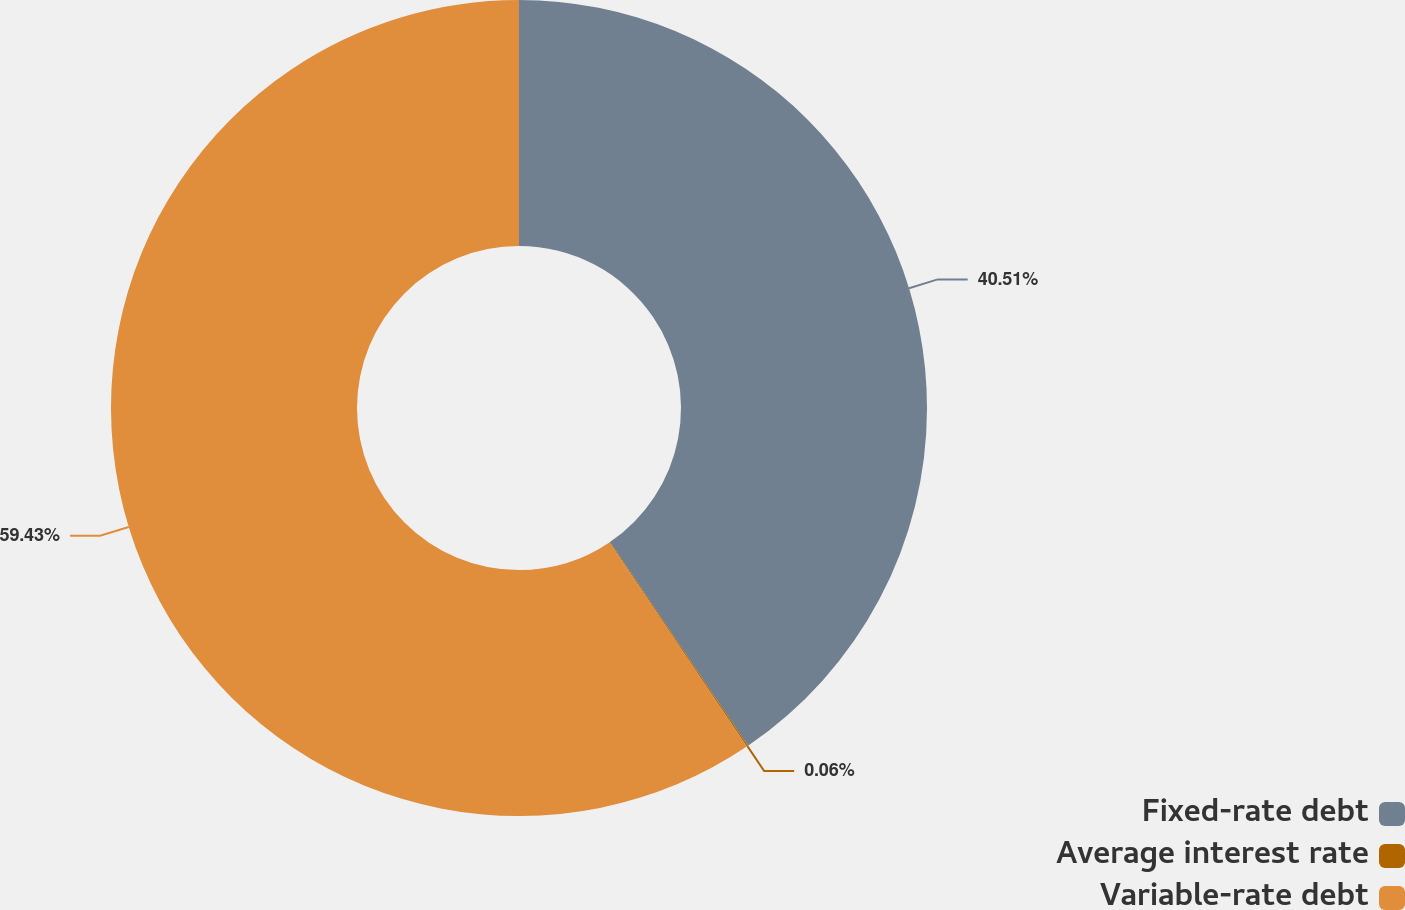Convert chart to OTSL. <chart><loc_0><loc_0><loc_500><loc_500><pie_chart><fcel>Fixed-rate debt<fcel>Average interest rate<fcel>Variable-rate debt<nl><fcel>40.51%<fcel>0.06%<fcel>59.42%<nl></chart> 